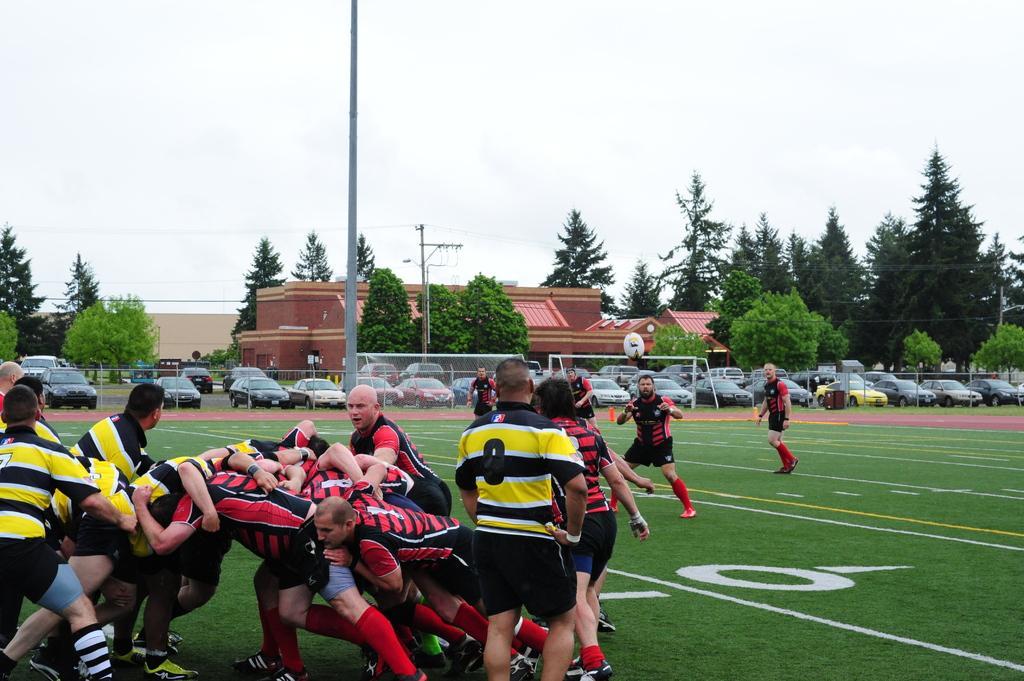Can you describe this image briefly? In this picture I can see there are a group of people playing in the play ground and they are wearing red and yellow color jersey´s and in the backdrop I can see there is a pole and a fence, there are cars parked here and there is a building and the sky is clear. 